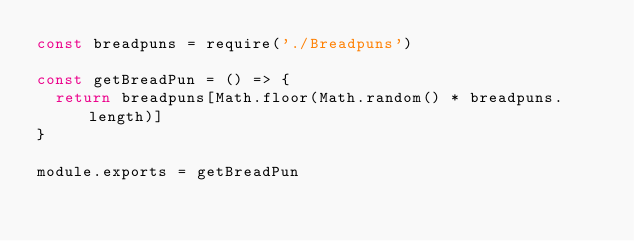Convert code to text. <code><loc_0><loc_0><loc_500><loc_500><_JavaScript_>const breadpuns = require('./Breadpuns')

const getBreadPun = () => {
  return breadpuns[Math.floor(Math.random() * breadpuns.length)]
}

module.exports = getBreadPun
</code> 